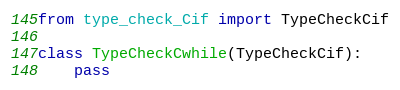<code> <loc_0><loc_0><loc_500><loc_500><_Python_>from type_check_Cif import TypeCheckCif

class TypeCheckCwhile(TypeCheckCif):
    pass
</code> 